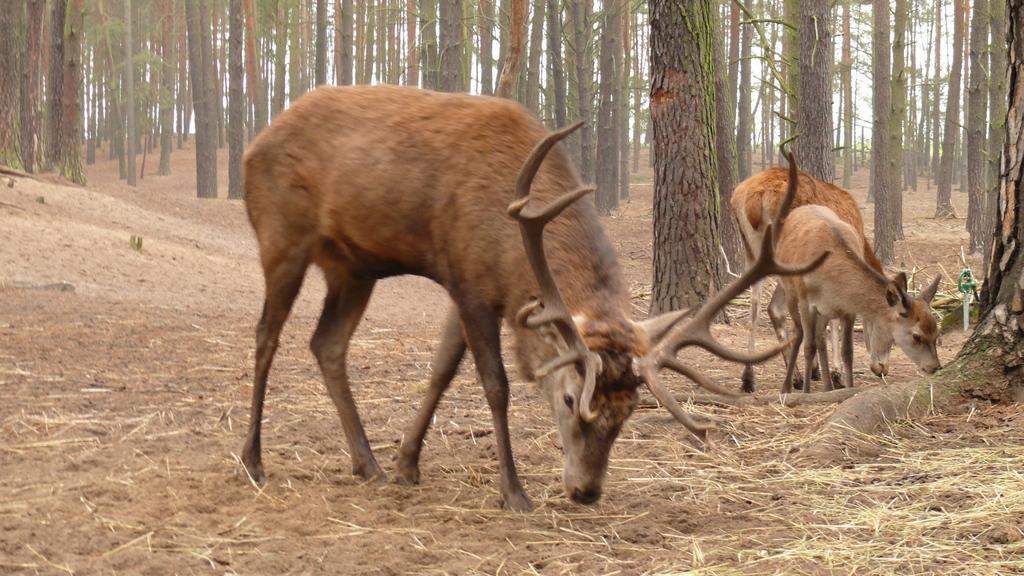In one or two sentences, can you explain what this image depicts? This image is taken outdoors. At the bottom of the image there is a ground and there is dry grass on the ground. In the background there are many trees with green leaves, stems and branches. In the middle of the image there are three deers grazing grass on the ground. 